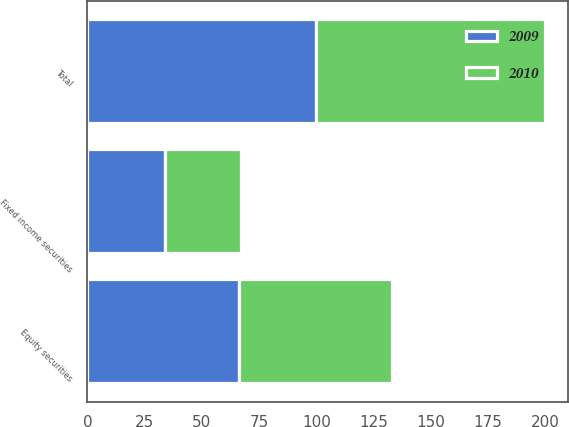<chart> <loc_0><loc_0><loc_500><loc_500><stacked_bar_chart><ecel><fcel>Equity securities<fcel>Fixed income securities<fcel>Total<nl><fcel>2010<fcel>67<fcel>33<fcel>100<nl><fcel>2009<fcel>66<fcel>34<fcel>100<nl></chart> 